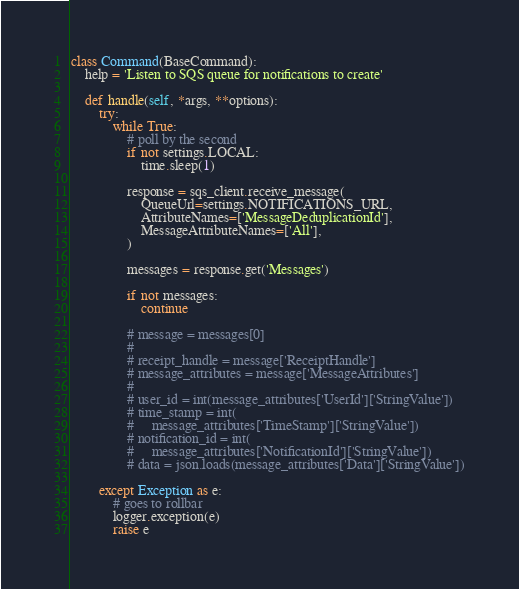<code> <loc_0><loc_0><loc_500><loc_500><_Python_>

class Command(BaseCommand):
    help = 'Listen to SQS queue for notifications to create'

    def handle(self, *args, **options):
        try:
            while True:
                # poll by the second
                if not settings.LOCAL:
                    time.sleep(1)

                response = sqs_client.receive_message(
                    QueueUrl=settings.NOTIFICATIONS_URL,
                    AttributeNames=['MessageDeduplicationId'],
                    MessageAttributeNames=['All'],
                )

                messages = response.get('Messages')

                if not messages:
                    continue

                # message = messages[0]
                #
                # receipt_handle = message['ReceiptHandle']
                # message_attributes = message['MessageAttributes']
                #
                # user_id = int(message_attributes['UserId']['StringValue'])
                # time_stamp = int(
                #     message_attributes['TimeStamp']['StringValue'])
                # notification_id = int(
                #     message_attributes['NotificationId']['StringValue'])
                # data = json.loads(message_attributes['Data']['StringValue'])

        except Exception as e:
            # goes to rollbar
            logger.exception(e)
            raise e
</code> 